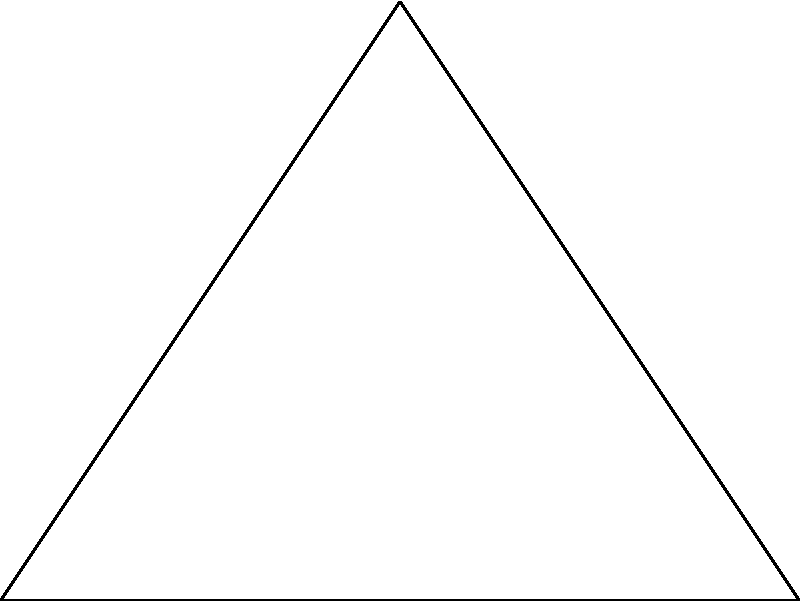Two major insurance companies, A and B, are planning to merge and need to determine the distance between their headquarters. A satellite positioned above them forms a right-angled triangle with the two locations. The satellite is directly above the midpoint between the two headquarters. If the angle between the satellite and Company A's headquarters is 60°, and the distance between the two companies along the ground is 8 km, what is the distance from the satellite to Company B's headquarters? Let's approach this step-by-step:

1) First, we need to identify the given information:
   - The triangle is right-angled
   - The angle at Company A is 60°
   - The distance between A and B is 8 km
   - The satellite is directly above the midpoint of AB

2) Since the satellite is above the midpoint, we can divide the base of the triangle into two equal parts of 4 km each.

3) In the right triangle formed by the satellite and Company A:
   - We know the angle (60°) and want to find the hypotenuse
   - The adjacent side to this angle is 4 km (half of AB)

4) We can use the cosine function to find the hypotenuse:

   $$\cos 60° = \frac{\text{adjacent}}{\text{hypotenuse}} = \frac{4}{\text{hypotenuse}}$$

5) Solving for the hypotenuse:

   $$\text{hypotenuse} = \frac{4}{\cos 60°} = \frac{4}{0.5} = 8 \text{ km}$$

6) This hypotenuse is the distance from the satellite to Company B's headquarters.

Therefore, the distance from the satellite to Company B's headquarters is 8 km.
Answer: 8 km 